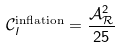<formula> <loc_0><loc_0><loc_500><loc_500>\mathcal { C } _ { l } ^ { \text {inflation} } = \frac { \mathcal { A } ^ { 2 } _ { \mathcal { R } } } { 2 5 }</formula> 